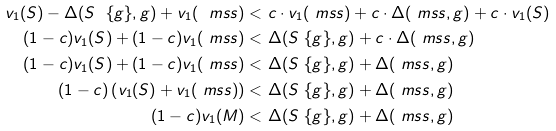Convert formula to latex. <formula><loc_0><loc_0><loc_500><loc_500>v _ { 1 } ( S ) - \Delta ( S \ \{ g \} , g ) + v _ { 1 } ( \ m s s ) < & \ c \cdot v _ { 1 } ( \ m s s ) + c \cdot \Delta ( \ m s s , g ) + c \cdot v _ { 1 } ( S ) \\ ( 1 - c ) v _ { 1 } ( S ) + ( 1 - c ) v _ { 1 } ( \ m s s ) < & \ \Delta ( S \ \{ g \} , g ) + c \cdot \Delta ( \ m s s , g ) \\ ( 1 - c ) v _ { 1 } ( S ) + ( 1 - c ) v _ { 1 } ( \ m s s ) < & \ \Delta ( S \ \{ g \} , g ) + \Delta ( \ m s s , g ) \\ ( 1 - c ) \left ( v _ { 1 } ( S ) + v _ { 1 } ( \ m s s ) \right ) < & \ \Delta ( S \ \{ g \} , g ) + \Delta ( \ m s s , g ) \\ ( 1 - c ) v _ { 1 } ( M ) < & \ \Delta ( S \ \{ g \} , g ) + \Delta ( \ m s s , g ) \\</formula> 